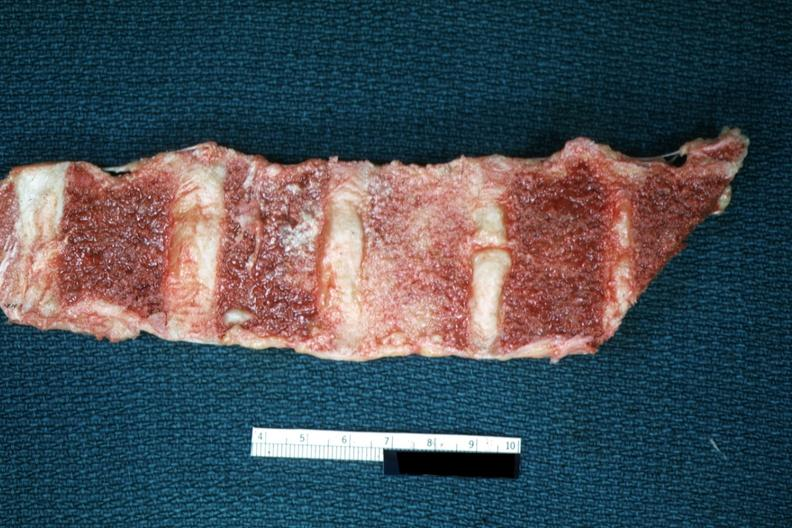what does this image show?
Answer the question using a single word or phrase. Section of vertebrae with osteoblastic metastasis 